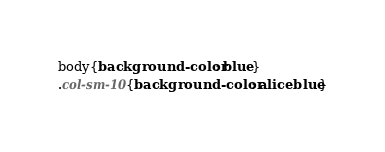<code> <loc_0><loc_0><loc_500><loc_500><_CSS_>body{background-color: blue}
.col-sm-10{background-color: aliceblue}</code> 